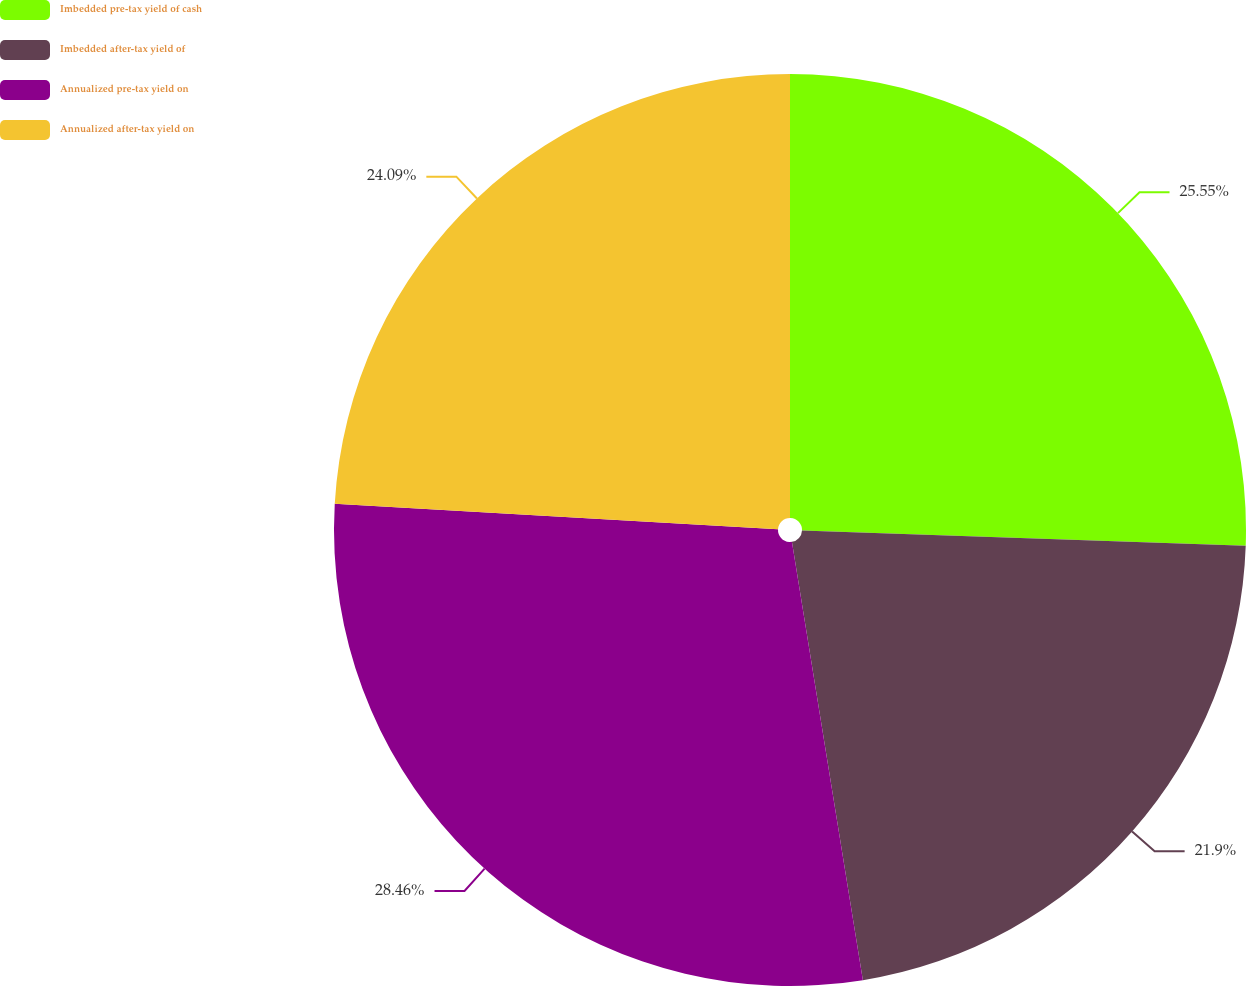<chart> <loc_0><loc_0><loc_500><loc_500><pie_chart><fcel>Imbedded pre-tax yield of cash<fcel>Imbedded after-tax yield of<fcel>Annualized pre-tax yield on<fcel>Annualized after-tax yield on<nl><fcel>25.55%<fcel>21.9%<fcel>28.47%<fcel>24.09%<nl></chart> 